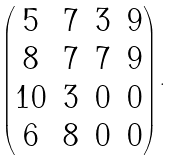<formula> <loc_0><loc_0><loc_500><loc_500>\begin{pmatrix} 5 & 7 & 3 & 9 \\ 8 & 7 & 7 & 9 \\ 1 0 & 3 & 0 & 0 \\ 6 & 8 & 0 & 0 \end{pmatrix} .</formula> 